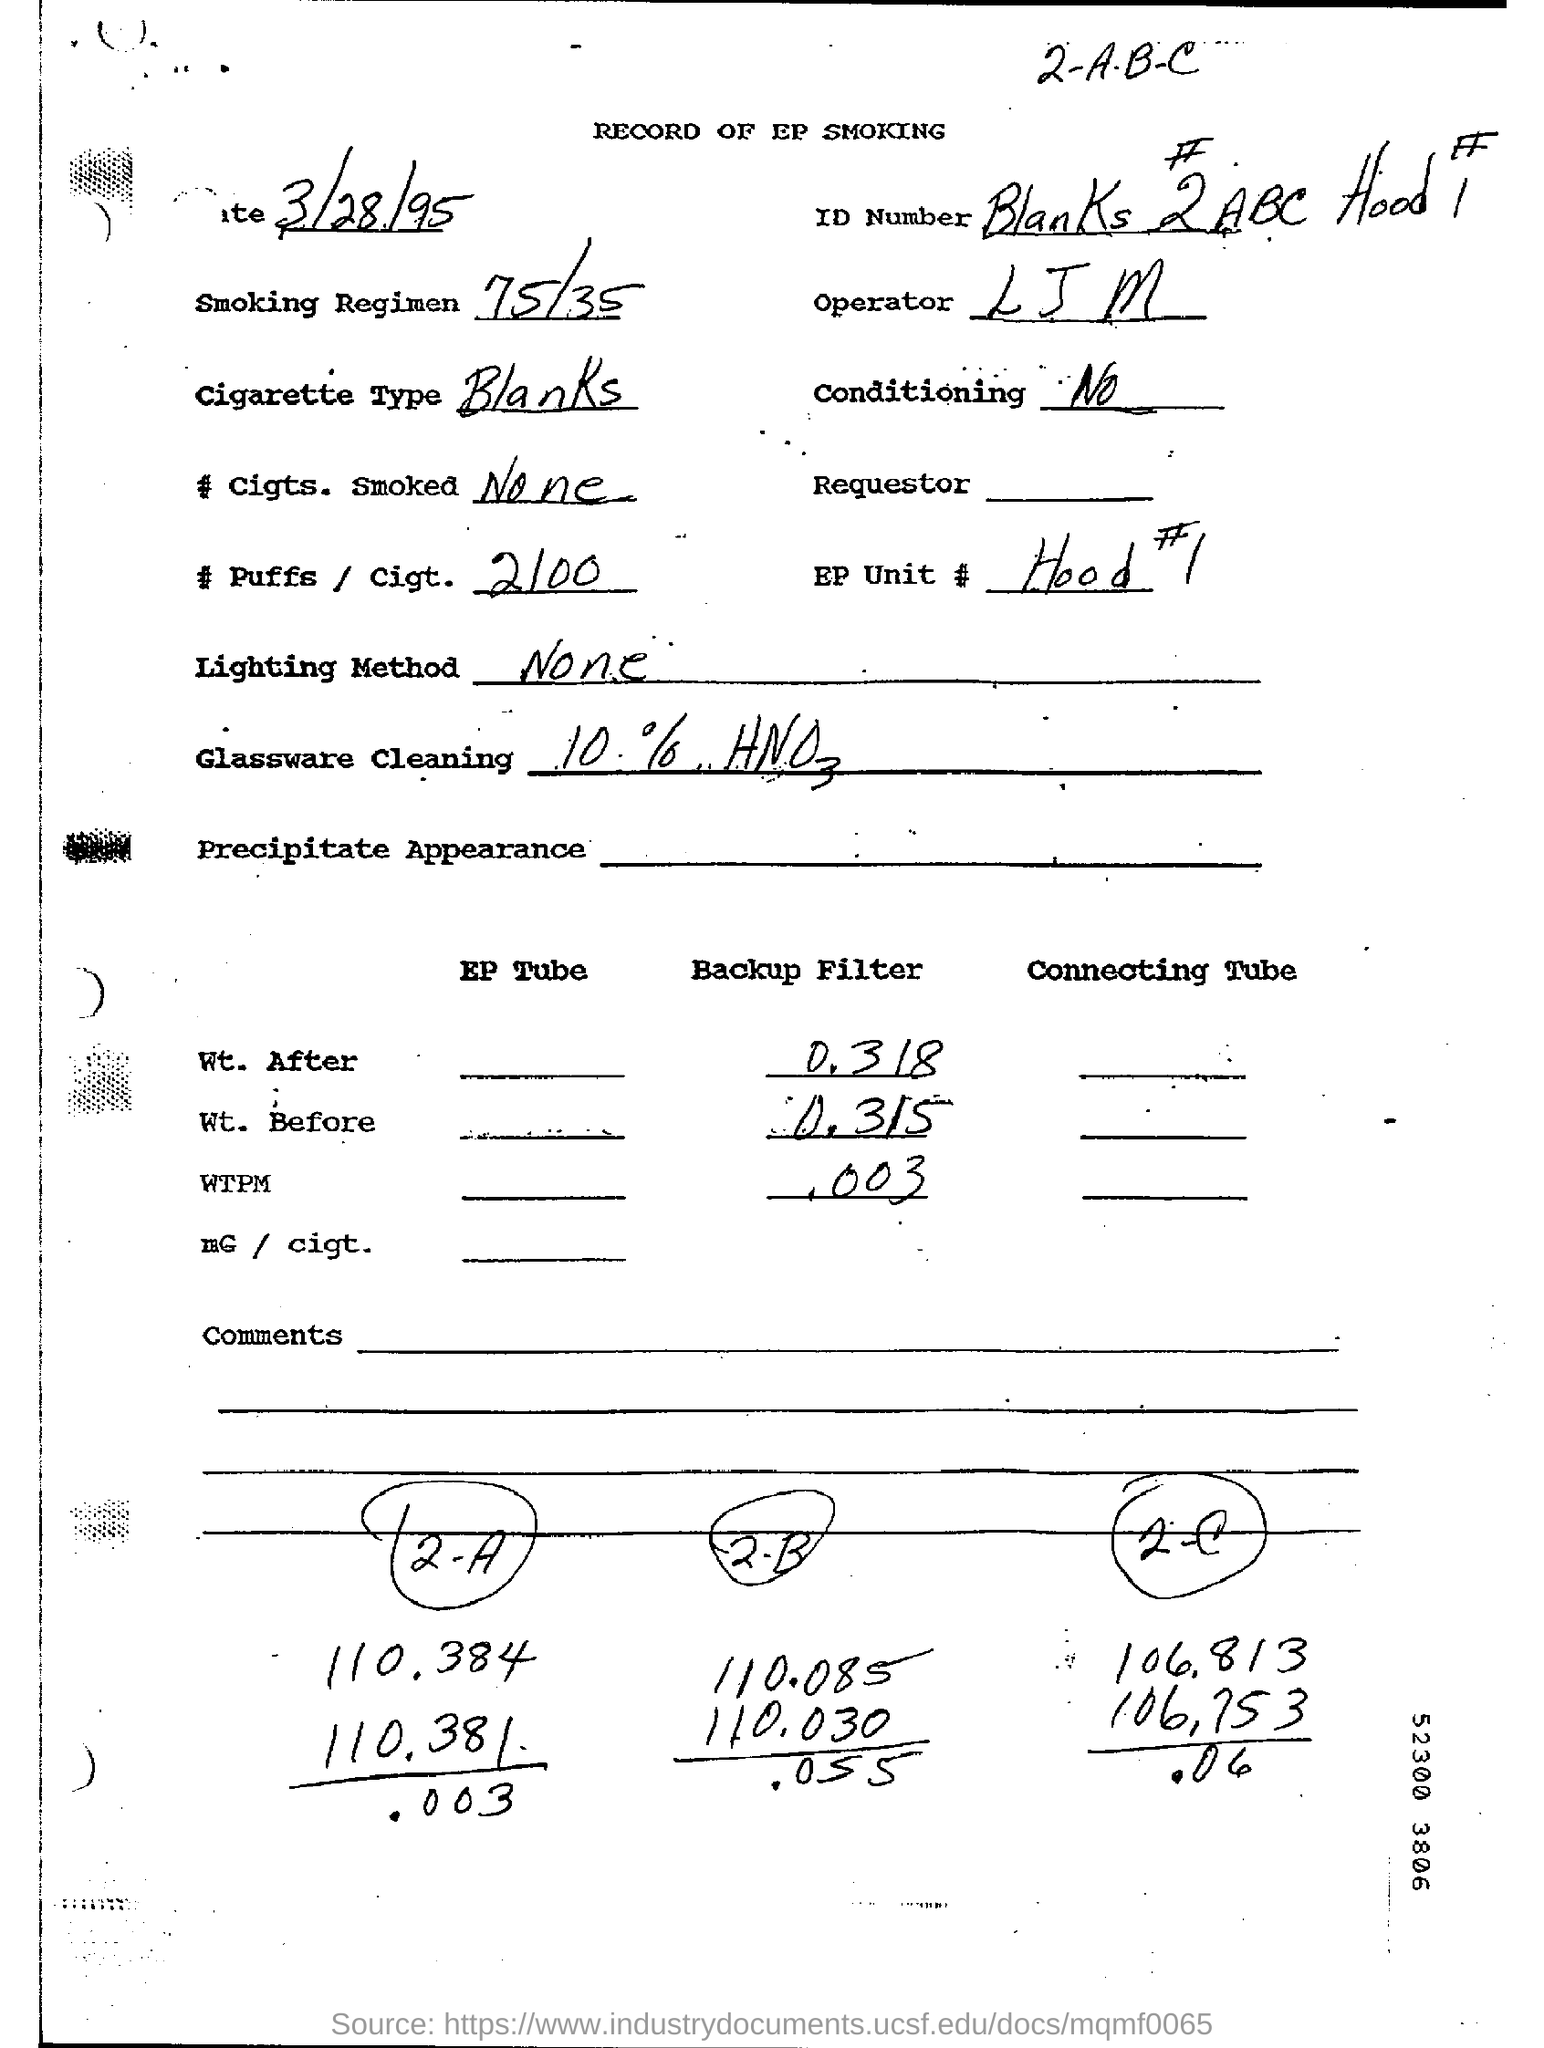What is the Smoking Regimen?
Provide a short and direct response. 75/35. What is the Cigarette Type?
Your response must be concise. Blanks. 